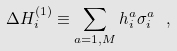<formula> <loc_0><loc_0><loc_500><loc_500>\Delta H ^ { ( 1 ) } _ { i } \equiv \sum _ { a = 1 , M } h ^ { a } _ { i } \sigma ^ { a } _ { i } \ ,</formula> 